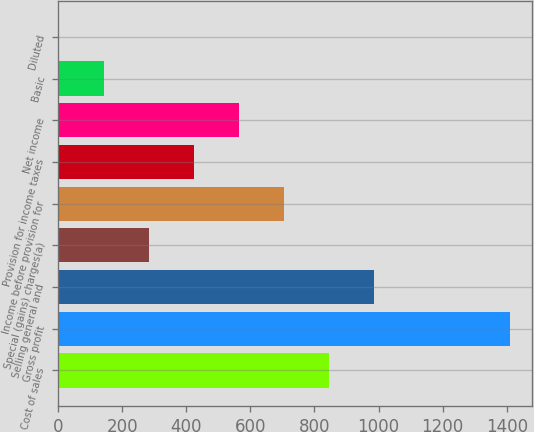<chart> <loc_0><loc_0><loc_500><loc_500><bar_chart><fcel>Cost of sales<fcel>Gross profit<fcel>Selling general and<fcel>Special (gains) charges(a)<fcel>Income before provision for<fcel>Provision for income taxes<fcel>Net income<fcel>Basic<fcel>Diluted<nl><fcel>846.12<fcel>1408.6<fcel>986.73<fcel>283.68<fcel>705.51<fcel>424.29<fcel>564.9<fcel>143.07<fcel>2.46<nl></chart> 